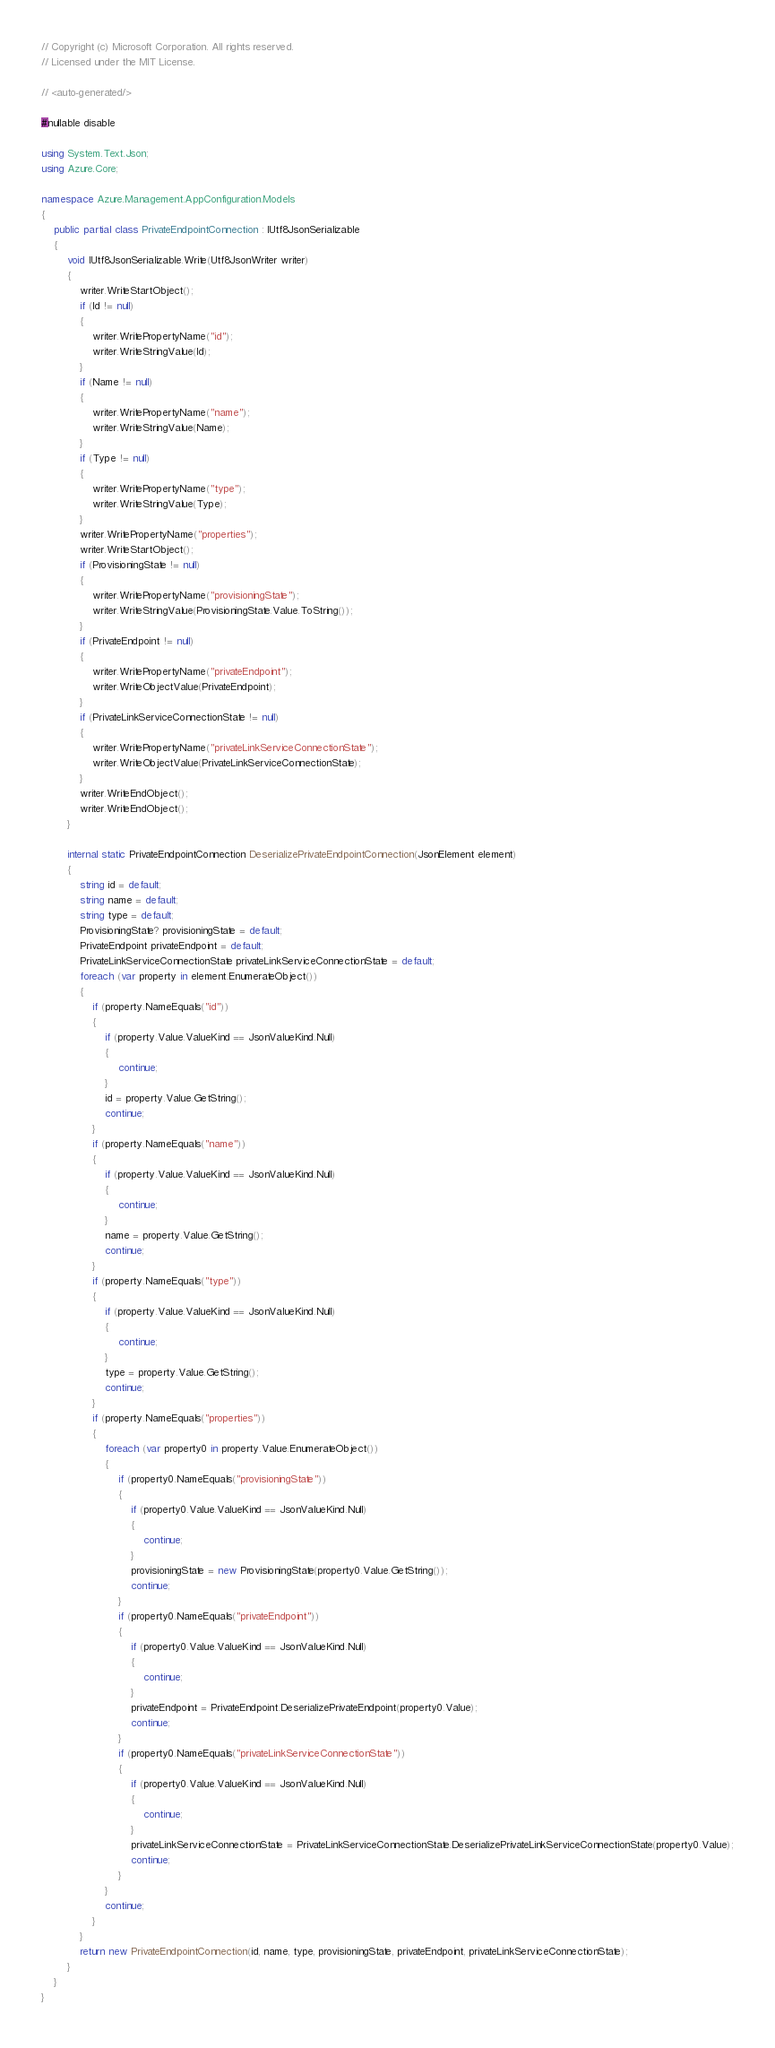<code> <loc_0><loc_0><loc_500><loc_500><_C#_>// Copyright (c) Microsoft Corporation. All rights reserved.
// Licensed under the MIT License.

// <auto-generated/>

#nullable disable

using System.Text.Json;
using Azure.Core;

namespace Azure.Management.AppConfiguration.Models
{
    public partial class PrivateEndpointConnection : IUtf8JsonSerializable
    {
        void IUtf8JsonSerializable.Write(Utf8JsonWriter writer)
        {
            writer.WriteStartObject();
            if (Id != null)
            {
                writer.WritePropertyName("id");
                writer.WriteStringValue(Id);
            }
            if (Name != null)
            {
                writer.WritePropertyName("name");
                writer.WriteStringValue(Name);
            }
            if (Type != null)
            {
                writer.WritePropertyName("type");
                writer.WriteStringValue(Type);
            }
            writer.WritePropertyName("properties");
            writer.WriteStartObject();
            if (ProvisioningState != null)
            {
                writer.WritePropertyName("provisioningState");
                writer.WriteStringValue(ProvisioningState.Value.ToString());
            }
            if (PrivateEndpoint != null)
            {
                writer.WritePropertyName("privateEndpoint");
                writer.WriteObjectValue(PrivateEndpoint);
            }
            if (PrivateLinkServiceConnectionState != null)
            {
                writer.WritePropertyName("privateLinkServiceConnectionState");
                writer.WriteObjectValue(PrivateLinkServiceConnectionState);
            }
            writer.WriteEndObject();
            writer.WriteEndObject();
        }

        internal static PrivateEndpointConnection DeserializePrivateEndpointConnection(JsonElement element)
        {
            string id = default;
            string name = default;
            string type = default;
            ProvisioningState? provisioningState = default;
            PrivateEndpoint privateEndpoint = default;
            PrivateLinkServiceConnectionState privateLinkServiceConnectionState = default;
            foreach (var property in element.EnumerateObject())
            {
                if (property.NameEquals("id"))
                {
                    if (property.Value.ValueKind == JsonValueKind.Null)
                    {
                        continue;
                    }
                    id = property.Value.GetString();
                    continue;
                }
                if (property.NameEquals("name"))
                {
                    if (property.Value.ValueKind == JsonValueKind.Null)
                    {
                        continue;
                    }
                    name = property.Value.GetString();
                    continue;
                }
                if (property.NameEquals("type"))
                {
                    if (property.Value.ValueKind == JsonValueKind.Null)
                    {
                        continue;
                    }
                    type = property.Value.GetString();
                    continue;
                }
                if (property.NameEquals("properties"))
                {
                    foreach (var property0 in property.Value.EnumerateObject())
                    {
                        if (property0.NameEquals("provisioningState"))
                        {
                            if (property0.Value.ValueKind == JsonValueKind.Null)
                            {
                                continue;
                            }
                            provisioningState = new ProvisioningState(property0.Value.GetString());
                            continue;
                        }
                        if (property0.NameEquals("privateEndpoint"))
                        {
                            if (property0.Value.ValueKind == JsonValueKind.Null)
                            {
                                continue;
                            }
                            privateEndpoint = PrivateEndpoint.DeserializePrivateEndpoint(property0.Value);
                            continue;
                        }
                        if (property0.NameEquals("privateLinkServiceConnectionState"))
                        {
                            if (property0.Value.ValueKind == JsonValueKind.Null)
                            {
                                continue;
                            }
                            privateLinkServiceConnectionState = PrivateLinkServiceConnectionState.DeserializePrivateLinkServiceConnectionState(property0.Value);
                            continue;
                        }
                    }
                    continue;
                }
            }
            return new PrivateEndpointConnection(id, name, type, provisioningState, privateEndpoint, privateLinkServiceConnectionState);
        }
    }
}
</code> 